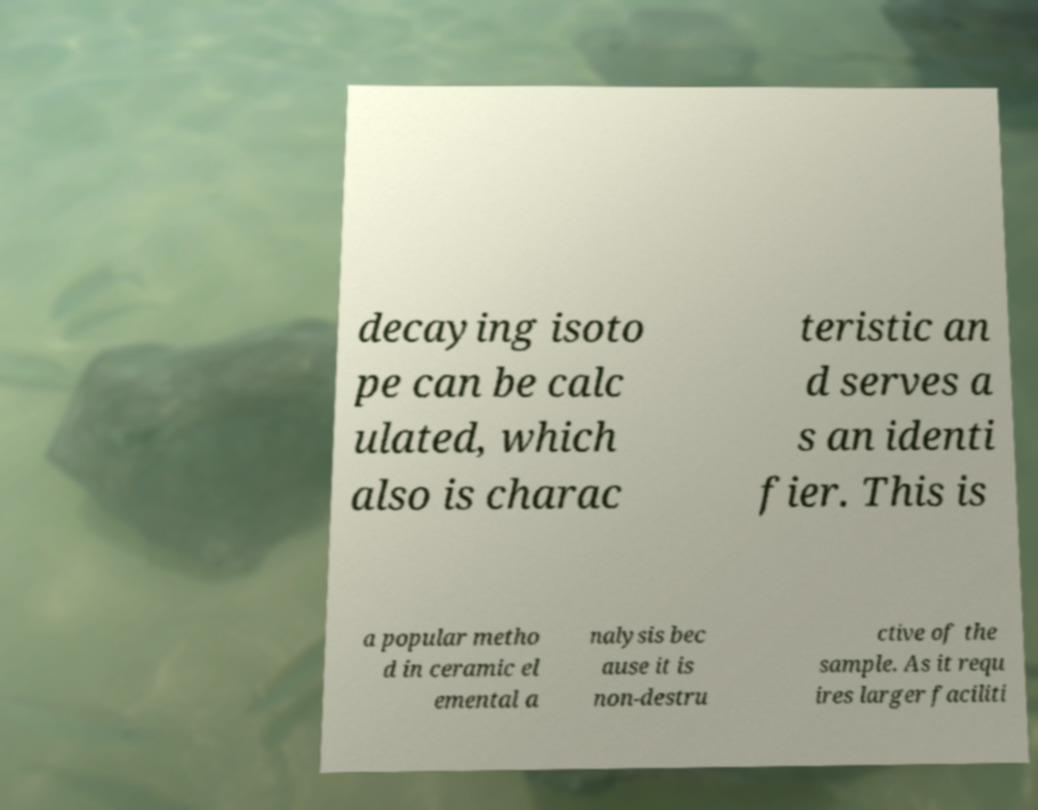Could you assist in decoding the text presented in this image and type it out clearly? decaying isoto pe can be calc ulated, which also is charac teristic an d serves a s an identi fier. This is a popular metho d in ceramic el emental a nalysis bec ause it is non-destru ctive of the sample. As it requ ires larger faciliti 